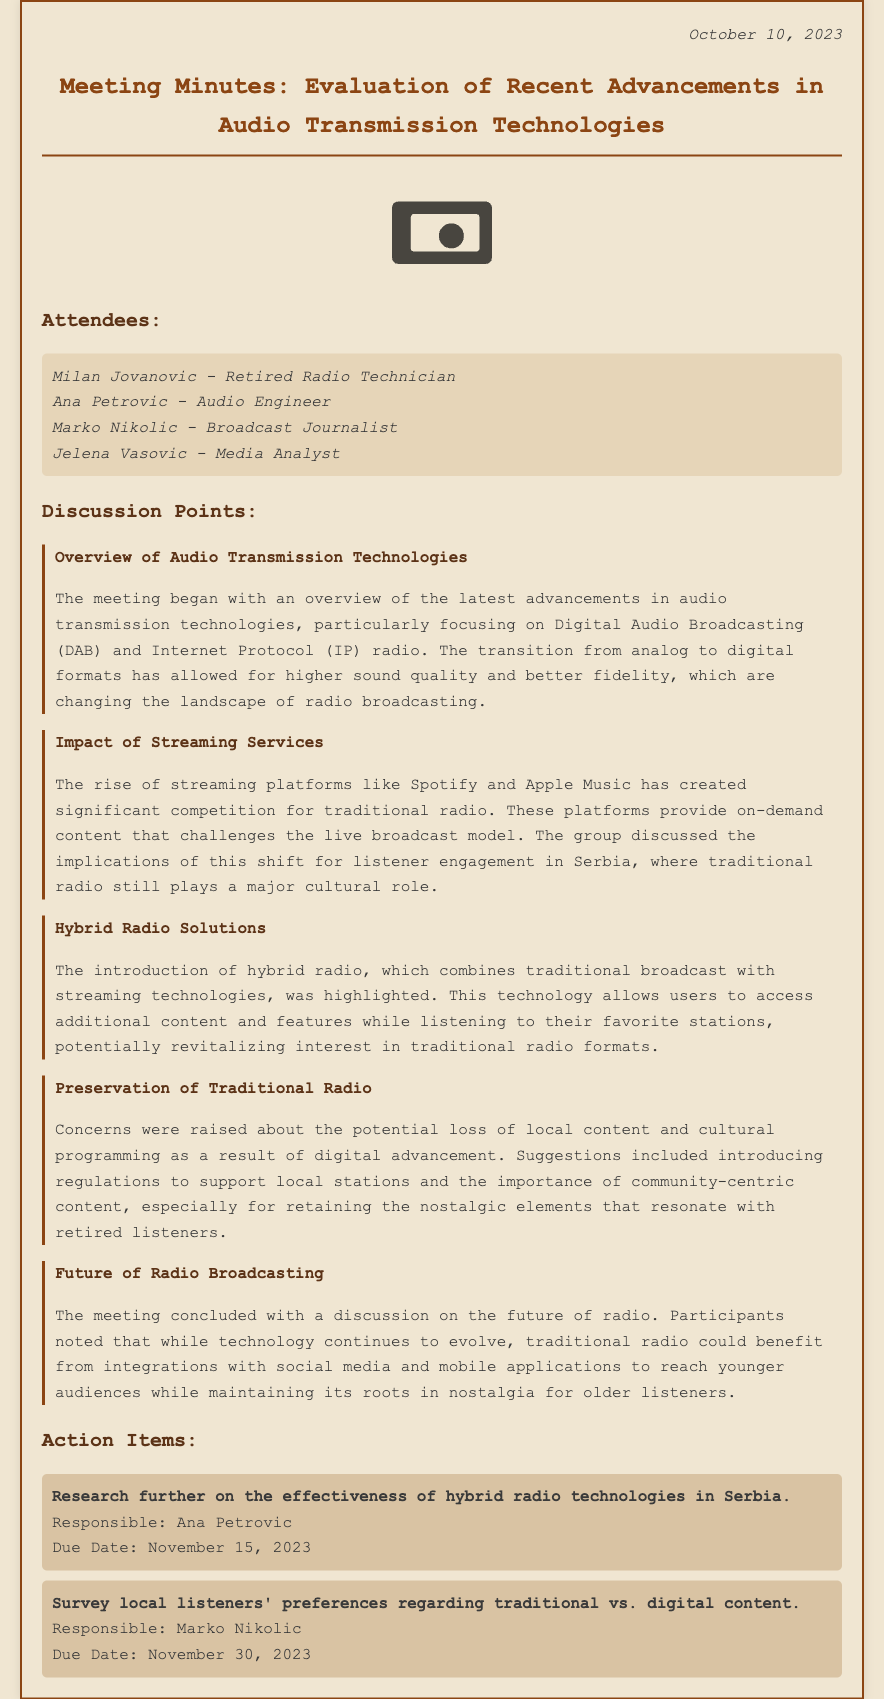What is the date of the meeting? The date of the meeting is mentioned at the top of the document.
Answer: October 10, 2023 Who is the responsible person for researching hybrid radio technologies? The person responsible for the action item regarding hybrid radio technologies is listed under the action items section.
Answer: Ana Petrovic What technology allows for higher sound quality in radio broadcasting? The technology is highlighted in the overview section of the discussion points.
Answer: Digital Audio Broadcasting Which streaming platforms were mentioned as competitors to traditional radio? The specific platforms are discussed under the impact of streaming services section.
Answer: Spotify and Apple Music What is one concern raised about digital advancements? This concern is noted under the preservation of traditional radio section of the document.
Answer: Loss of local content How does hybrid radio enhance the listening experience? The enhancement is described in the discussion on hybrid radio solutions.
Answer: Combines traditional broadcast with streaming technologies What action item is due on November 30, 2023? The specific action item is outlined in the action items section.
Answer: Survey local listeners' preferences regarding traditional vs. digital content What role does traditional radio still play in Serbia? The role is discussed in the context of streaming services and listener engagement.
Answer: Major cultural role What topic concludes the meeting discussions? The final discussion point regarding the future of radio broadcasting wraps up the meeting.
Answer: Future of Radio Broadcasting 